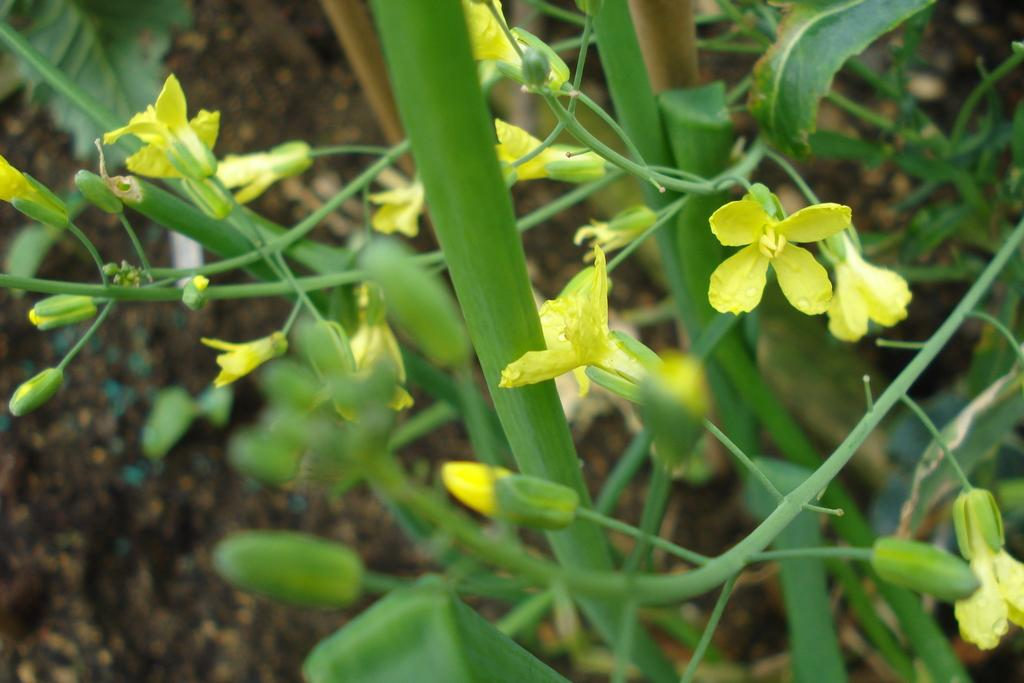What color are the flowers on the plant in the image? The flowers on the plant are yellow. What stage of growth are some of the flowers in? There are buds on the plant, indicating that some flowers are not yet fully bloomed. What can be seen at the bottom of the image? There is mud at the bottom of the image. What type of advice can be heard from the plane in the image? There is no plane present in the image, so no advice can be heard from it. 